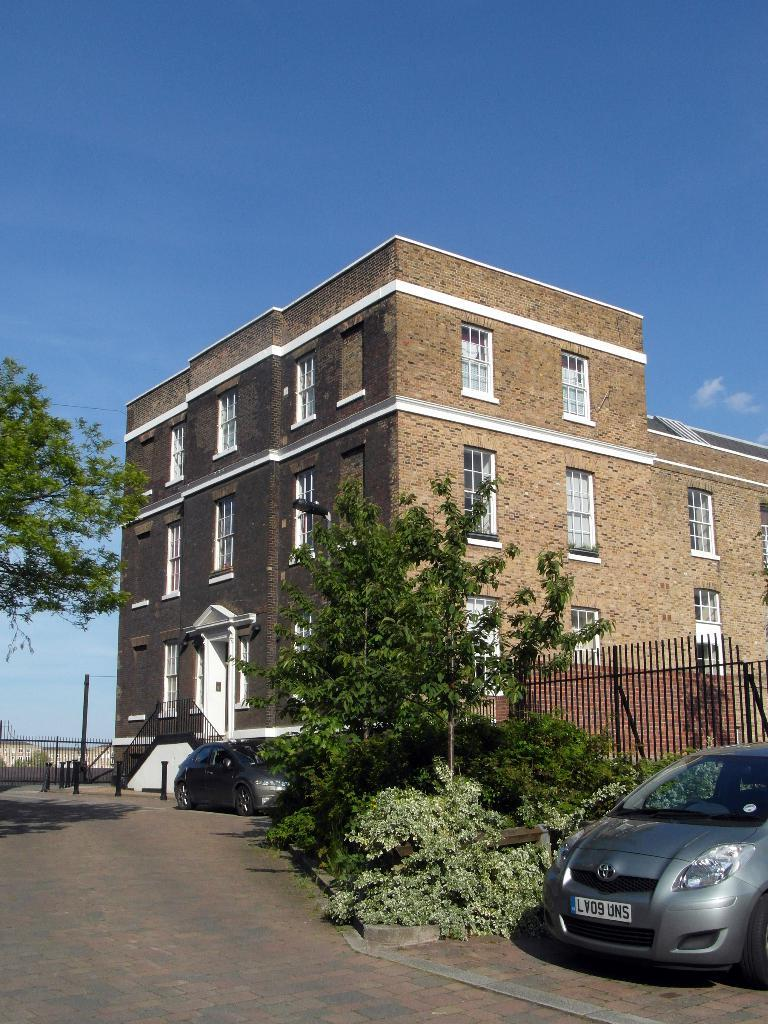What can be seen on the right side of the image? There are cars, plants, a fence, a building, windows, a pole, and a wall on the right side of the image. What is present on the left side of the image? There is a tree on the left side of the image. What is visible in the background of the image? The sky is visible in the background of the image, with clouds present. What is the birth rate of the territory depicted in the image? There is no territory or information about a birth rate present in the image. What season is depicted in the image? The image does not provide information about the season, but the presence of clouds in the sky suggests it could be any season. 